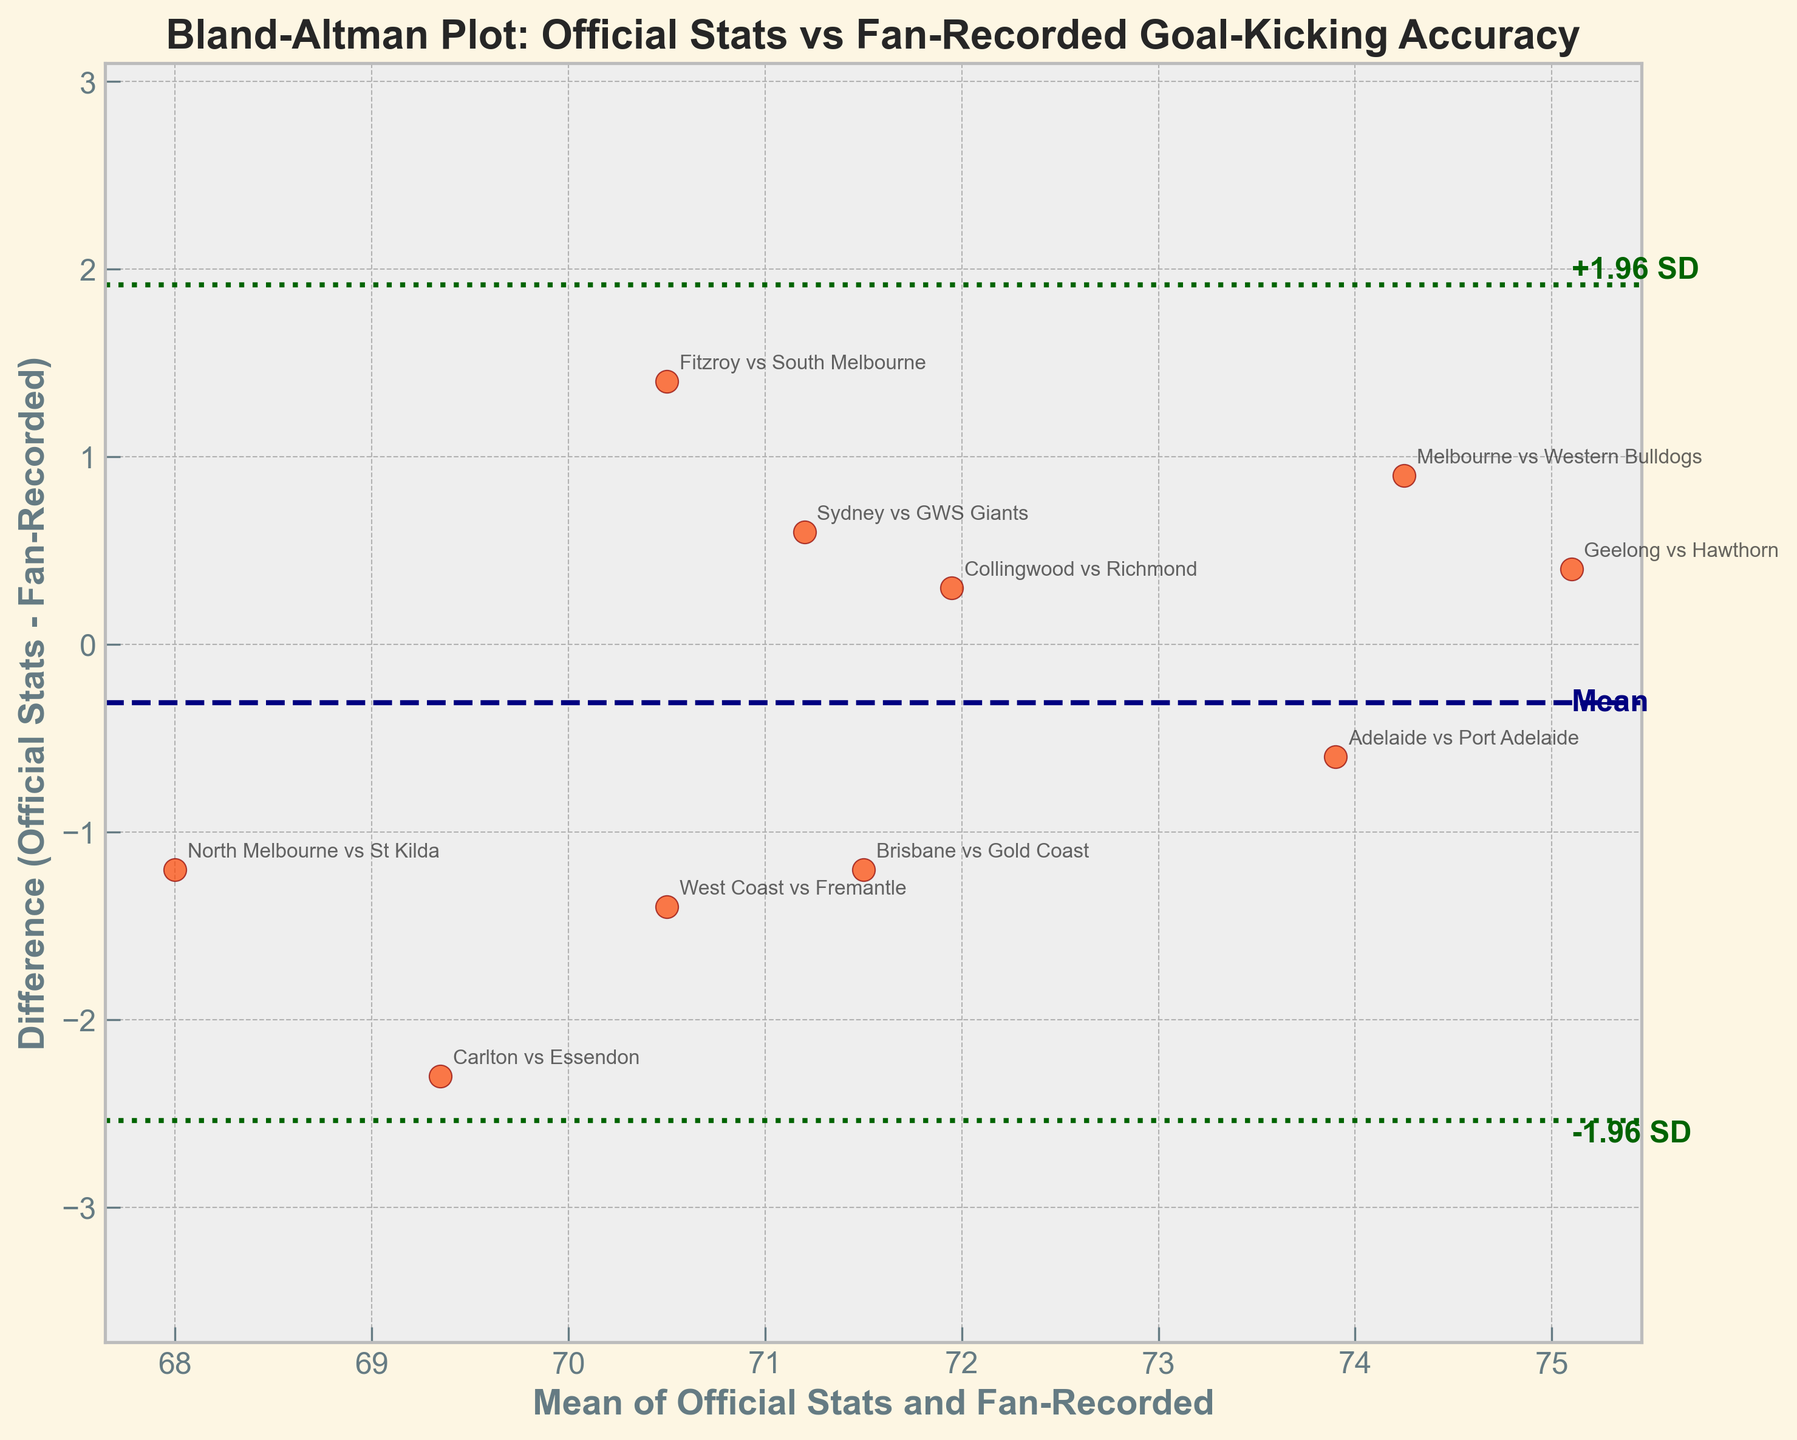What's the title of the plot? The title of the plot is displayed at the top of the figure and usually summarizes the data represented.
Answer: "Bland-Altman Plot: Official Stats vs Fan-Recorded Goal-Kicking Accuracy" How many data points are there in the plot? To determine the number of data points, count the plotted points in the scatter plot.
Answer: 10 Which team match-up has the smallest difference between Official Stats and Fan-Recorded? Evaluate the vertical distances of the points from the zero line, identifying the point closest to zero. "Collingwood vs Richmond" appears to be closest to zero.
Answer: "Collingwood vs Richmond" What is the average of the differences between Official Stats and Fan-Recorded? Find the mean difference by averaging the vertical distances of all points from the zero line. The mean line is depicted as the dashed navy line.
Answer: 0.23 Are there any outliers? Look for points that violate the dashed green lines (+1.96 SD and -1.96 SD). If none are obviously outside, there are no outliers.
Answer: No What range of values does the y-axis cover? Evaluate the y-axis limits visually. The range is from around -3 to 3.
Answer: Approximately -3 to 3 What does the solid navy horizontal line represent? This line indicates the mean difference between Official Stats and Fan-Recorded values.
Answer: The mean difference What's the purpose of the dashed green lines? These lines show the 95% limits of agreement, calculated as ±1.96 times the standard deviation of the differences.
Answer: 95% limits of agreement Is the Fan-Recorded data generally higher or lower than the Official Stats? Compare the relative positions of many points to the horizontal zero line. If more points are above, the Official Stats are higher; if more points are below, the Fan-Recorded data is higher. More points are slightly above the zero line.
Answer: Higher Which method showed higher goal-kicking accuracy in the match between Brisbane vs Gold Coast? First identify the data point for this match, then notice its position relative to the zero line: points above imply higher Official Stats while points below imply higher Fan-Recorded.
Answer: Fan-Recorded 